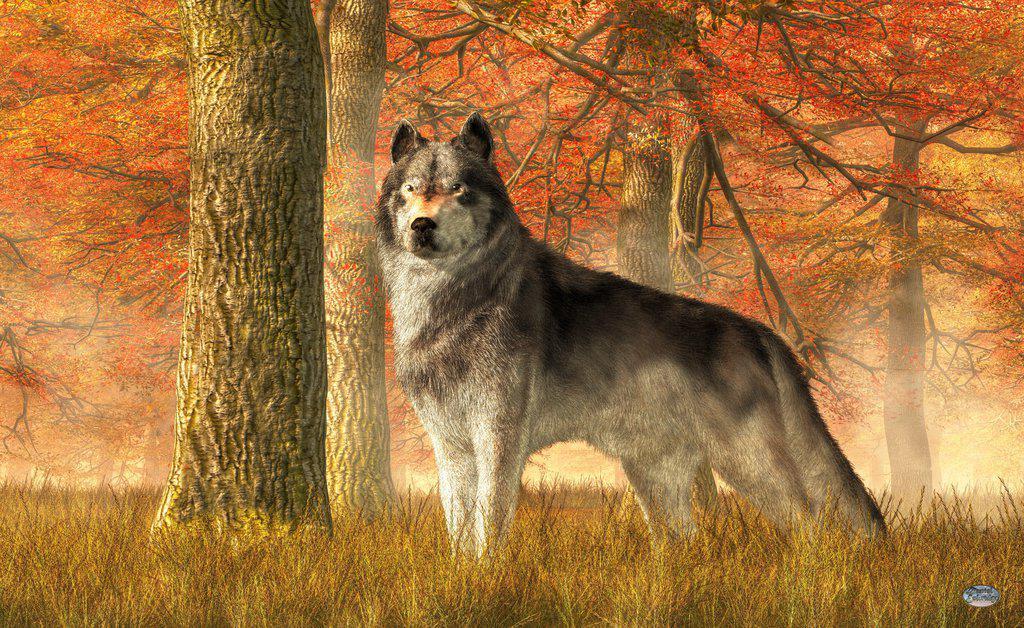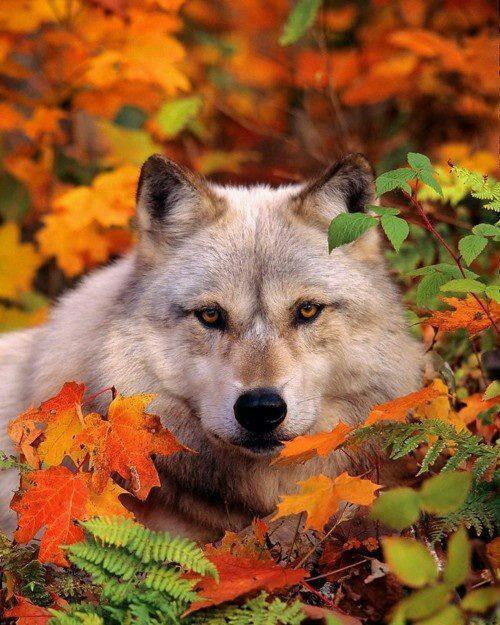The first image is the image on the left, the second image is the image on the right. Assess this claim about the two images: "There are only two wolves and neither of them are howling.". Correct or not? Answer yes or no. Yes. The first image is the image on the left, the second image is the image on the right. Evaluate the accuracy of this statement regarding the images: "Each image shows a single foreground wolf posed in a scene of colorful foliage.". Is it true? Answer yes or no. Yes. 